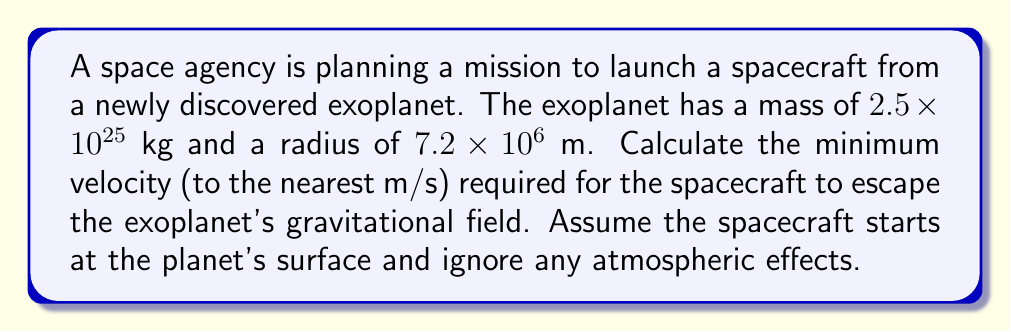Give your solution to this math problem. To solve this problem, we need to use the escape velocity equation:

$$v_e = \sqrt{\frac{2GM}{R}}$$

Where:
$v_e$ is the escape velocity
$G$ is the gravitational constant ($6.67430 \times 10^{-11}$ $\text{m}^3 \text{kg}^{-1} \text{s}^{-2}$)
$M$ is the mass of the planet
$R$ is the radius of the planet

Let's substitute the given values:

$M = 2.5 \times 10^{25}$ kg
$R = 7.2 \times 10^6$ m

Now, let's calculate:

$$\begin{align}
v_e &= \sqrt{\frac{2G(2.5 \times 10^{25})}{7.2 \times 10^6}} \\[10pt]
&= \sqrt{\frac{2(6.67430 \times 10^{-11})(2.5 \times 10^{25})}{7.2 \times 10^6}} \\[10pt]
&= \sqrt{\frac{3.33715 \times 10^{15}}{7.2 \times 10^6}} \\[10pt]
&= \sqrt{4.63493 \times 10^8} \\[10pt]
&= 21,529.26 \text{ m/s}
\end{align}$$

Rounding to the nearest m/s, we get 21,529 m/s.
Answer: 21,529 m/s 